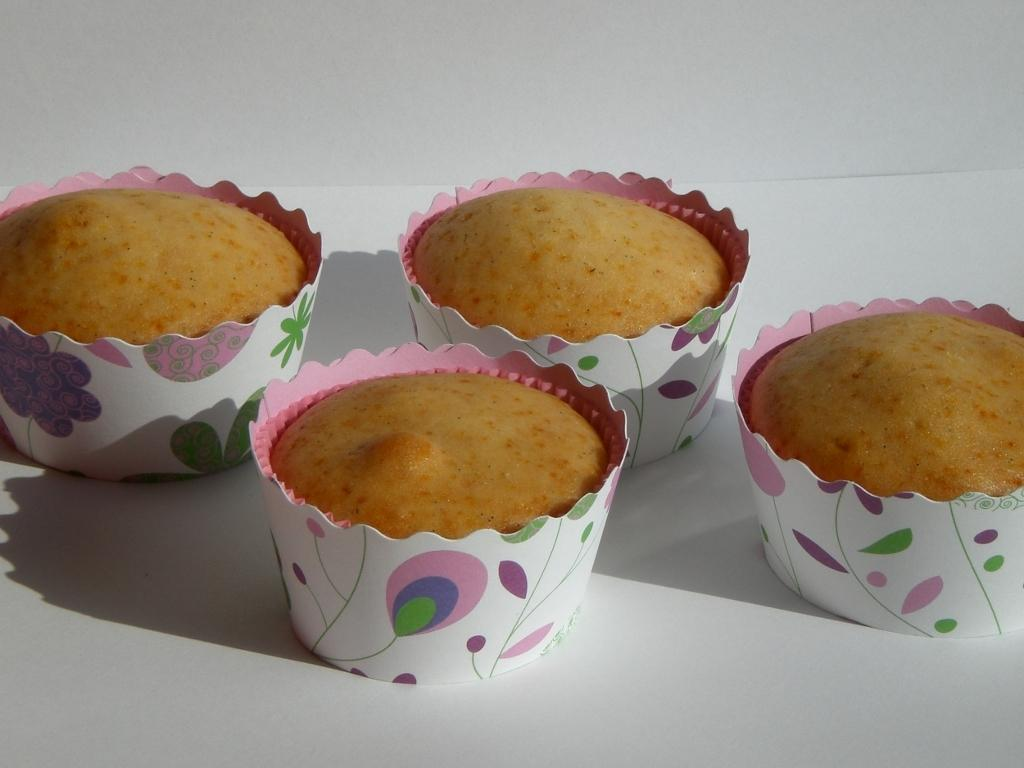How many cupcakes are visible in the image? There are four cupcakes in the image. Where are the cupcakes located? The cupcakes are on a table. What type of railway can be seen in the image? There is no railway present in the image; it features four cupcakes on a table. How many matches are used to light the candles on the cupcakes? There are no candles or matches present in the image, as it only shows four cupcakes on a table. 